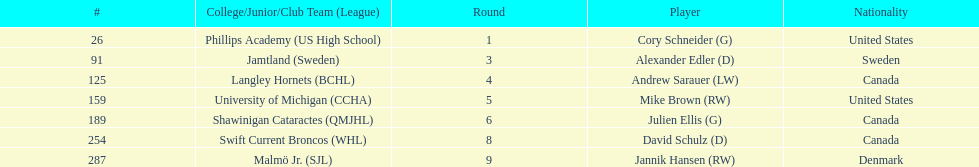How many players are from the united states? 2. 